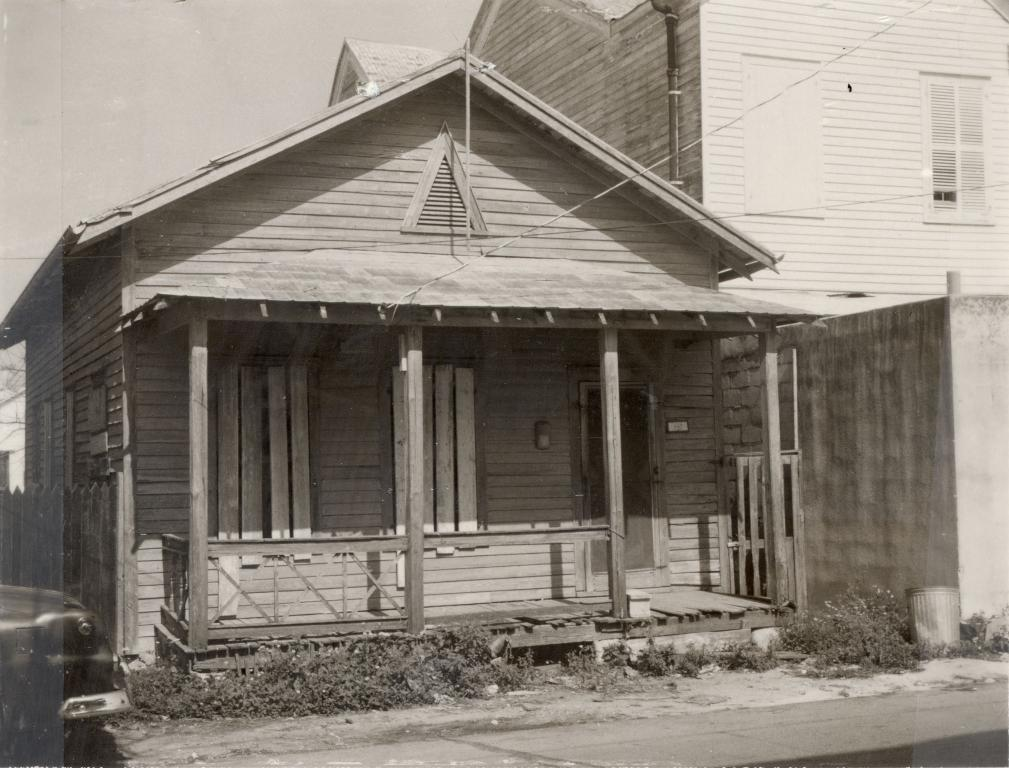What is the main subject of the image? There is a car on the road in the image. What type of vegetation can be seen in the image? There are plants in the image. What type of barrier is present in the image? There is a wooden fence in the image. What type of structure can be seen in the image? There is a stone wall and a wooden house in the image. What is visible in the background of the image? The sky is visible in the background of the image. What activity is the star participating in within the image? There is no star present in the image, so it cannot be participating in any activity. 